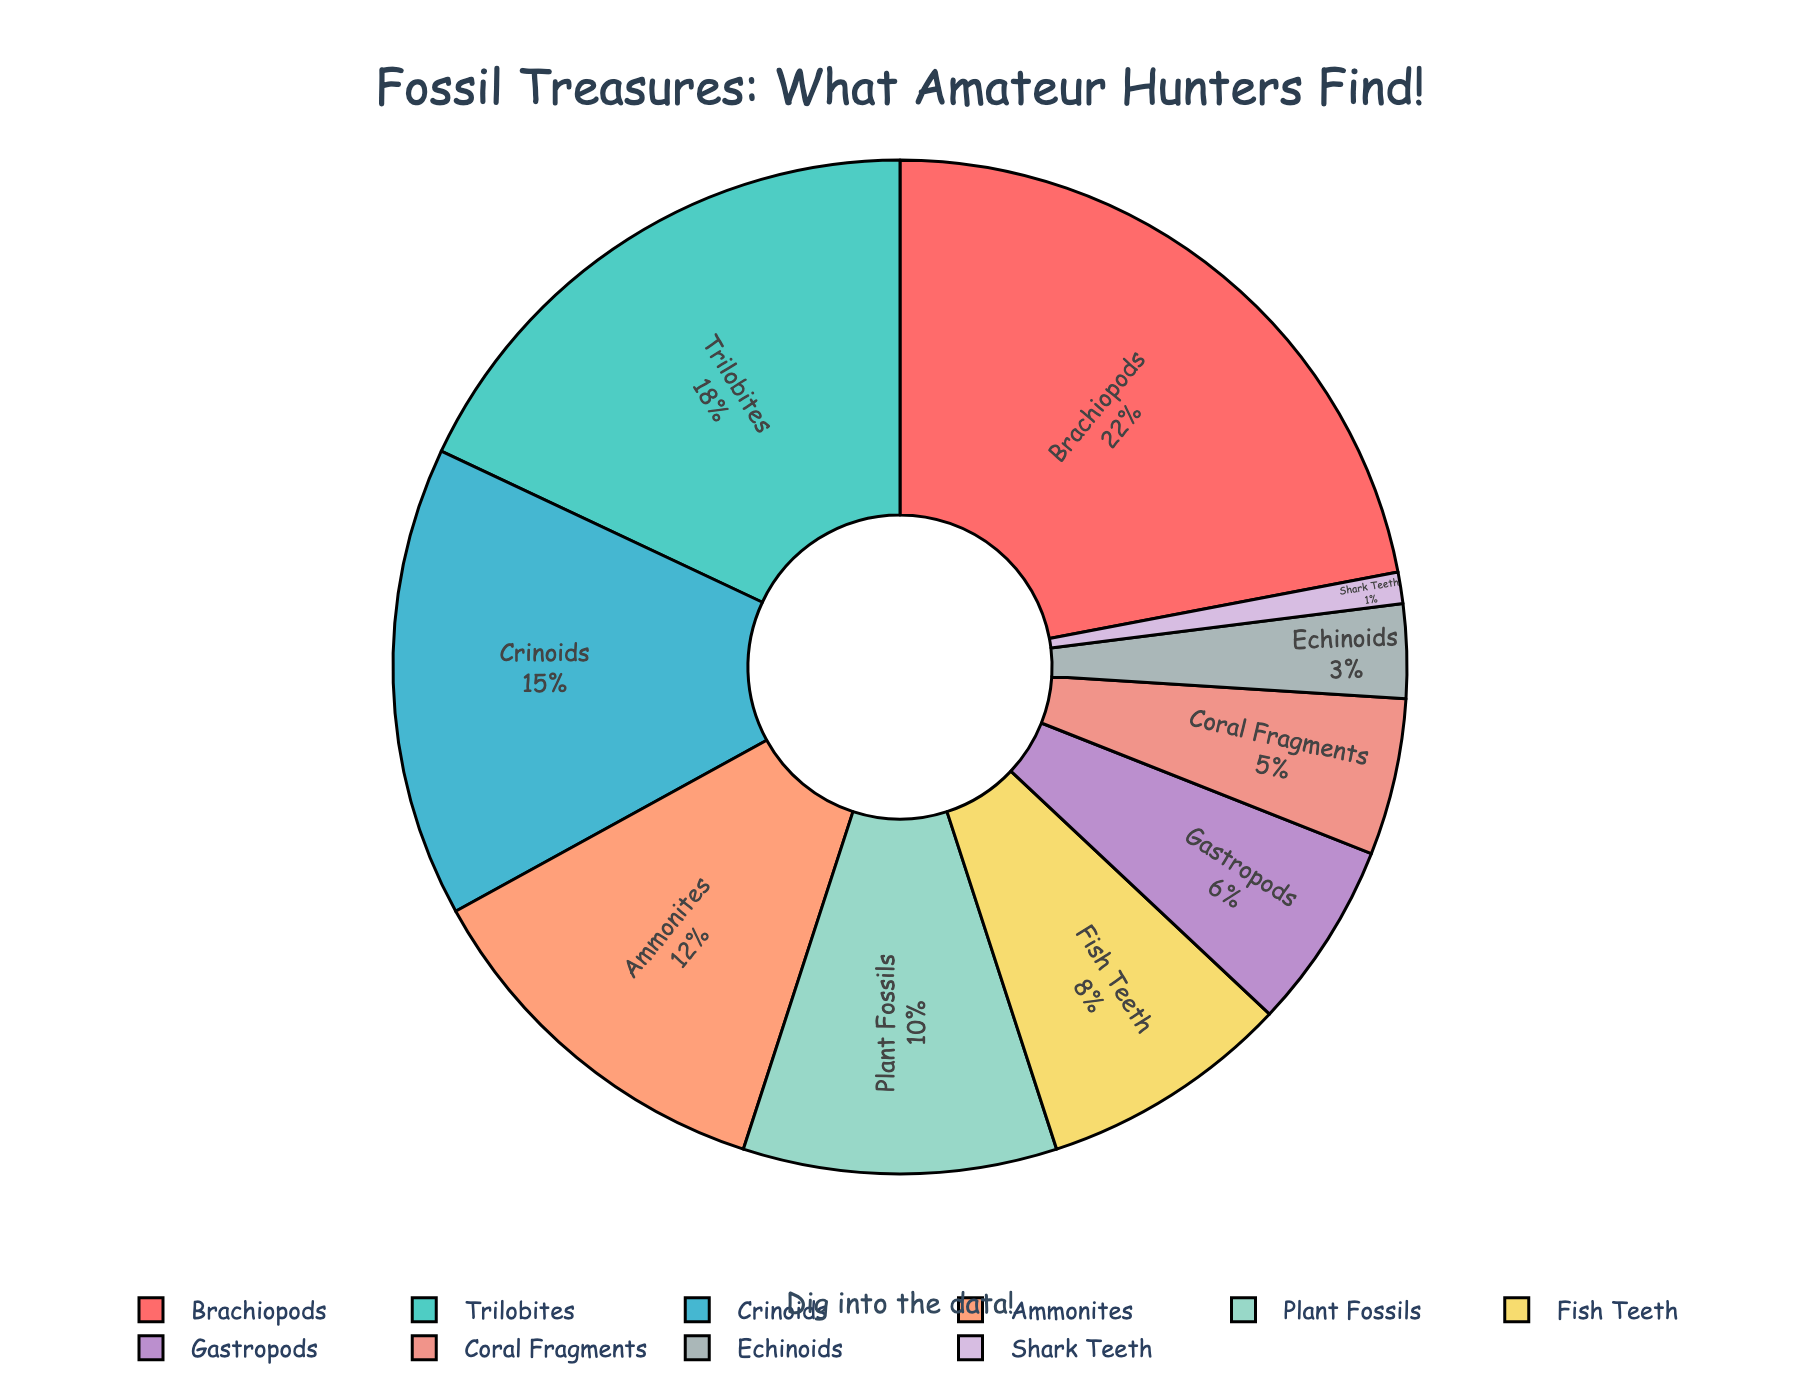What percentage of fossils found are plant fossils? Locate the Plant Fossils section in the pie chart and read the percentage.
Answer: 10% Which fossil type is the second most commonly found by amateur fossil hunters? Identify the largest section (Brachiopods at 22%) and then find the second largest section, which is Trilobites at 18%.
Answer: Trilobites How many fossil types have a percentage greater than 10%? Count the number of sections with percentages greater than 10%: Brachiopods (22%), Trilobites (18%), Crinoids (15%), and Ammonites (12%).
Answer: 4 Do brachiopods make up more or less than a quarter of the total fossils found? Brachiopods make up 22%, and a quarter is 25%. Since 22% is less than 25%, it's less than a quarter.
Answer: Less What is the combined percentage of Coral Fragments, Echinoids, and Shark Teeth? Add the percentages: Coral Fragments (5%) + Echinoids (3%) + Shark Teeth (1%) = 9%.
Answer: 9% Which fossil type has the least representation in the chart? Locate the smallest section, which corresponds to Shark Teeth at 1%.
Answer: Shark Teeth Are there more Brachiopods or Crinoids found? Compare the percentages: Brachiopods (22%) vs. Crinoids (15%). 22% is greater than 15%.
Answer: Brachiopods What is the difference in percentage between Fish Teeth and Gastropods? Subtract the smaller percentage (Gastropods, 6%) from the larger percentage (Fish Teeth, 8%): 8% - 6% = 2%.
Answer: 2% How many different fossil types are represented in the chart? Count the number of different sections labeled: Brachiopods, Trilobites, Crinoids, Ammonites, Plant Fossils, Fish Teeth, Gastropods, Coral Fragments, Echinoids, and Shark Teeth.
Answer: 10 What is the total percentage of fossils that are not Fish Teeth? Subtract the percentage of Fish Teeth from 100%: 100% - 8% = 92%.
Answer: 92% 